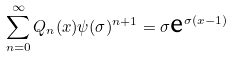<formula> <loc_0><loc_0><loc_500><loc_500>\sum _ { n = 0 } ^ { \infty } Q _ { n } ( x ) \psi ( \sigma ) ^ { n + 1 } = \sigma \text {e} ^ { \sigma ( x - 1 ) }</formula> 